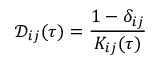<formula> <loc_0><loc_0><loc_500><loc_500>\mathcal { D } _ { i j } ( \tau ) = \frac { 1 - \delta _ { i j } } { K _ { i j } ( \tau ) }</formula> 